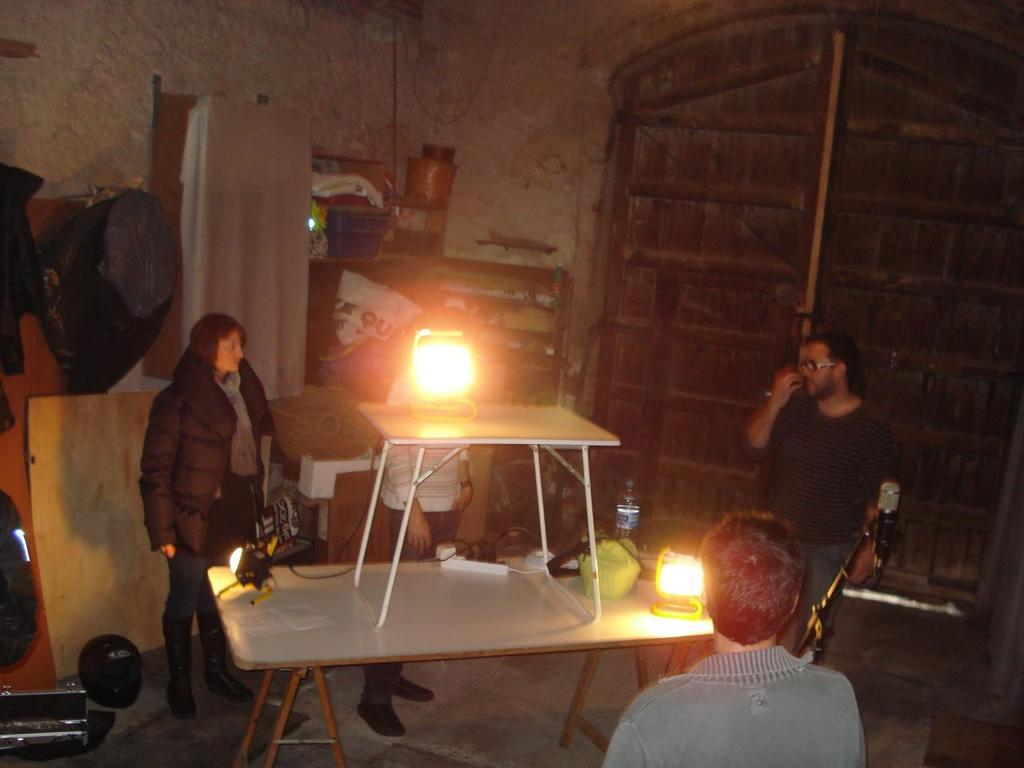How many people are visible in the image? There are four people visible in the image. Can you describe the positions of the people in the image? Three persons are standing in the front of the image, and another person is standing in the background. What objects can be seen on the table in the image? There are two lights on a table in the image. What items are present in the image that might be used for carrying or holding things? There is a ball and a bag in the image. What architectural feature is visible in the image? There is a door in the image. What type of corn can be seen growing near the door in the image? There is no corn present in the image; it features people, lights, a ball, a bag, and a door. 